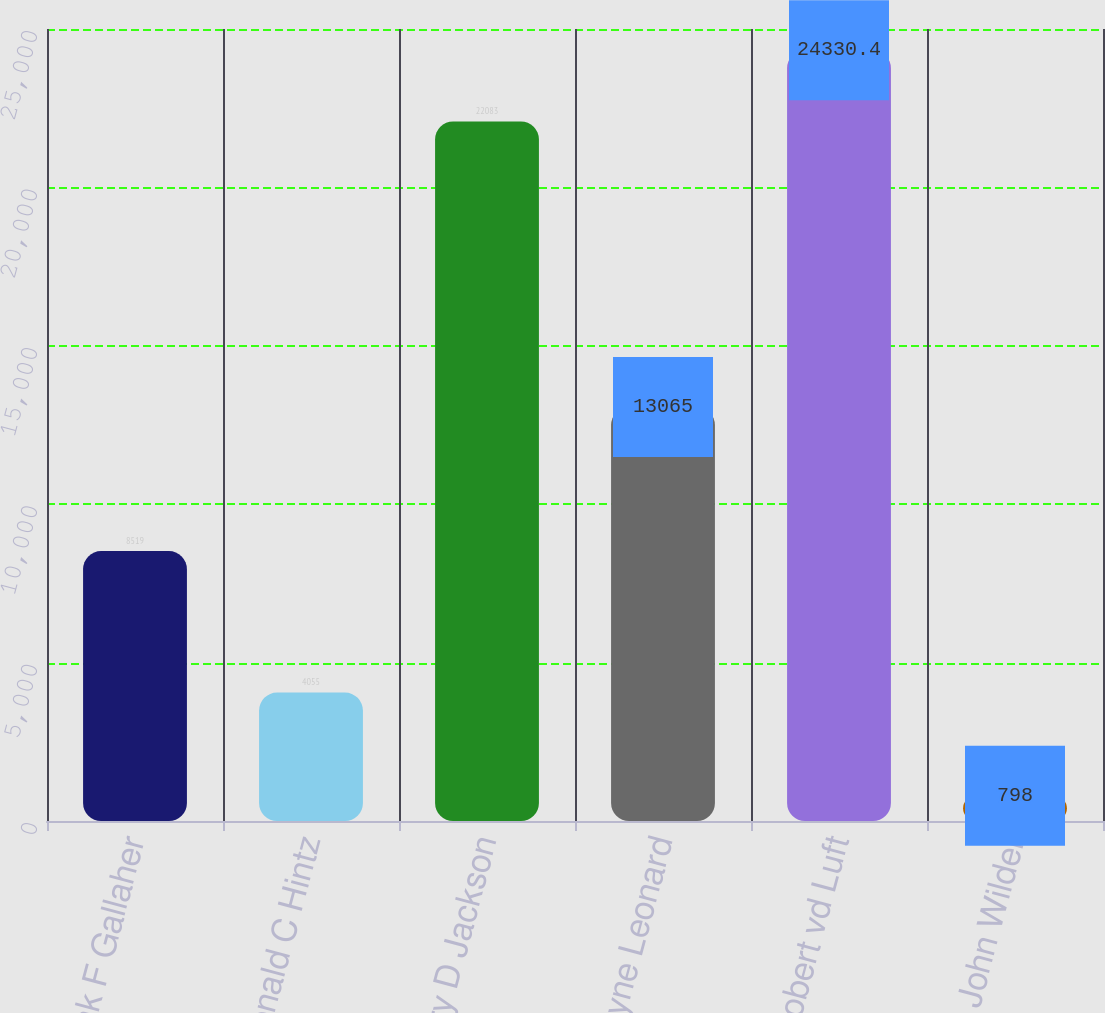<chart> <loc_0><loc_0><loc_500><loc_500><bar_chart><fcel>Frank F Gallaher<fcel>Donald C Hintz<fcel>Jerry D Jackson<fcel>J Wayne Leonard<fcel>Robert vd Luft<fcel>C John Wilder<nl><fcel>8519<fcel>4055<fcel>22083<fcel>13065<fcel>24330.4<fcel>798<nl></chart> 